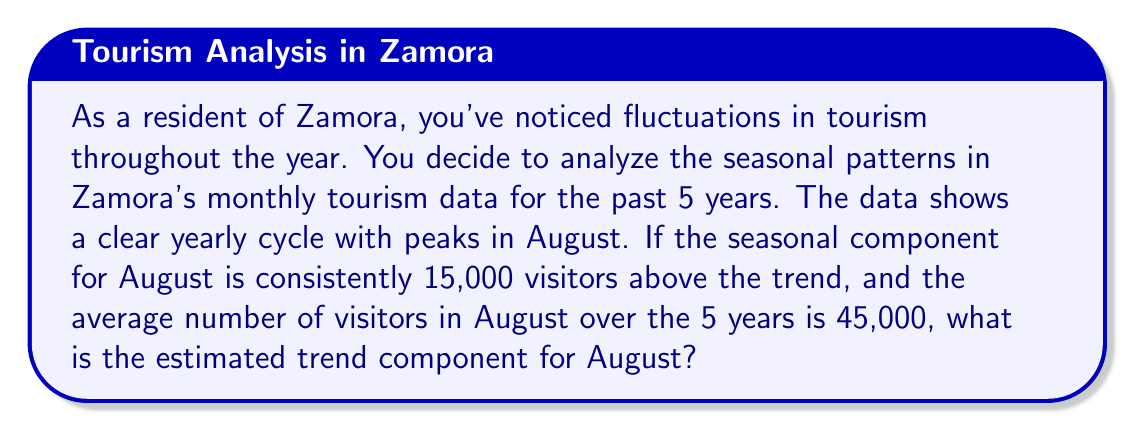Help me with this question. To solve this problem, we need to understand the components of a time series:

1. The observed value (Y) is composed of:
   $Y = T + S + I$
   Where T is the trend component, S is the seasonal component, and I is the irregular component.

2. In this case, we're given:
   - The seasonal component (S) for August is 15,000
   - The average number of visitors in August (Y) is 45,000

3. We can ignore the irregular component (I) as we're dealing with an average over 5 years, so it's likely to be close to zero.

4. Therefore, our equation becomes:
   $Y = T + S$

5. Substituting the known values:
   $45,000 = T + 15,000$

6. Solving for T:
   $T = 45,000 - 15,000 = 30,000$

Thus, the estimated trend component for August is 30,000 visitors.
Answer: 30,000 visitors 